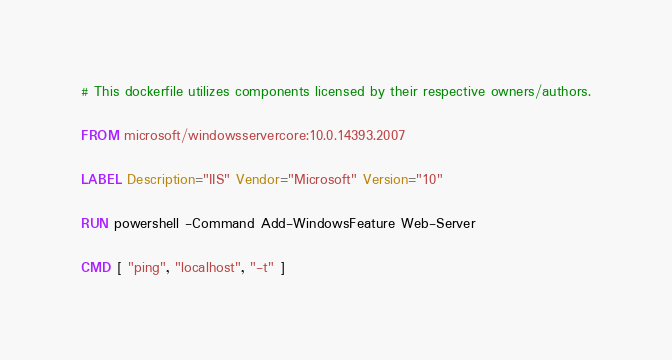<code> <loc_0><loc_0><loc_500><loc_500><_Dockerfile_># This dockerfile utilizes components licensed by their respective owners/authors.

FROM microsoft/windowsservercore:10.0.14393.2007

LABEL Description="IIS" Vendor="Microsoft" Version="10"

RUN powershell -Command Add-WindowsFeature Web-Server

CMD [ "ping", "localhost", "-t" ]
</code> 